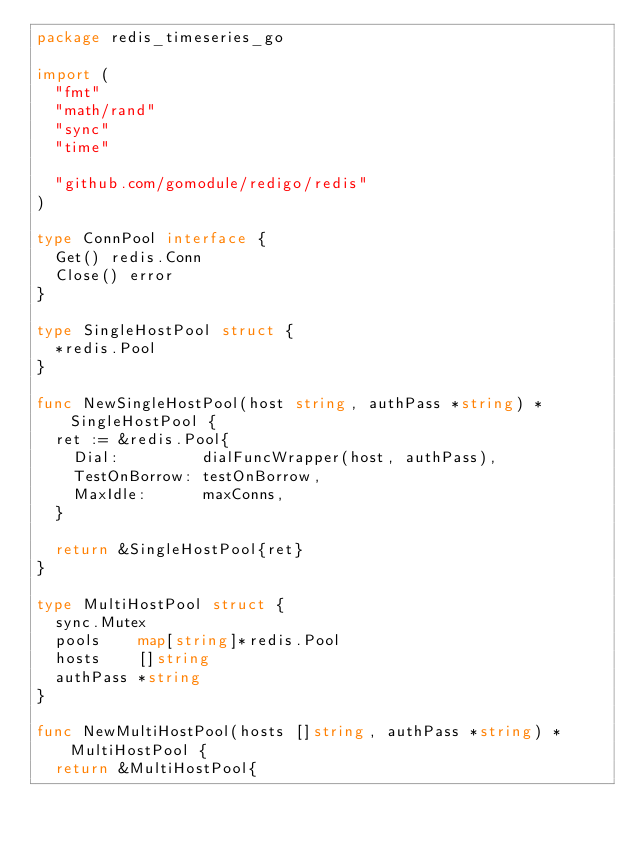<code> <loc_0><loc_0><loc_500><loc_500><_Go_>package redis_timeseries_go

import (
	"fmt"
	"math/rand"
	"sync"
	"time"

	"github.com/gomodule/redigo/redis"
)

type ConnPool interface {
	Get() redis.Conn
	Close() error
}

type SingleHostPool struct {
	*redis.Pool
}

func NewSingleHostPool(host string, authPass *string) *SingleHostPool {
	ret := &redis.Pool{
		Dial:         dialFuncWrapper(host, authPass),
		TestOnBorrow: testOnBorrow,
		MaxIdle:      maxConns,
	}

	return &SingleHostPool{ret}
}

type MultiHostPool struct {
	sync.Mutex
	pools    map[string]*redis.Pool
	hosts    []string
	authPass *string
}

func NewMultiHostPool(hosts []string, authPass *string) *MultiHostPool {
	return &MultiHostPool{</code> 